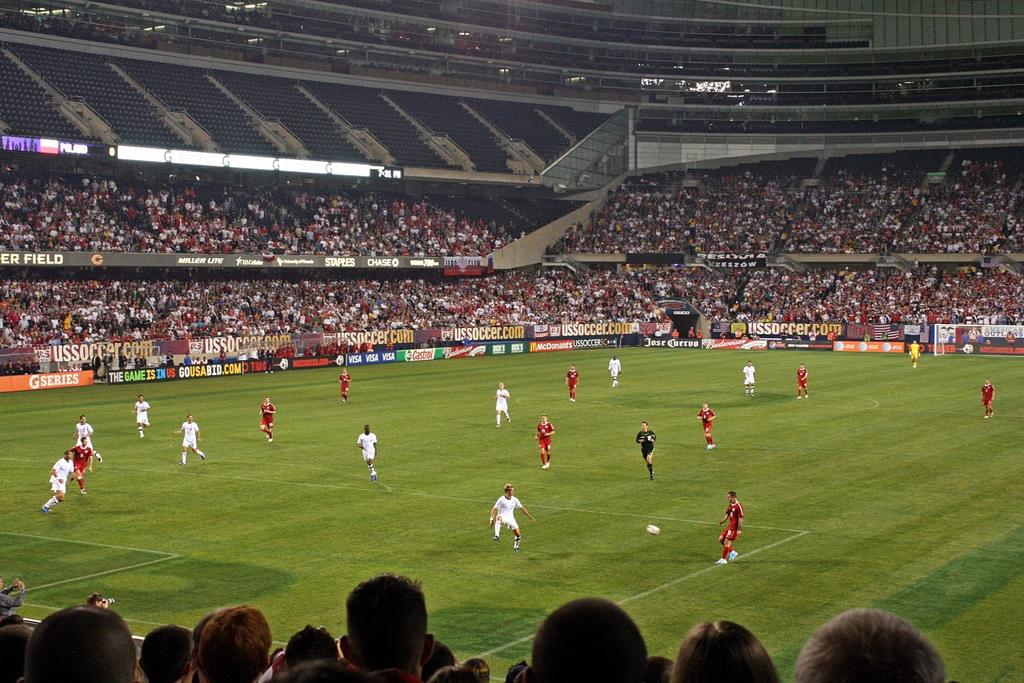What is us soccer's website?
Provide a succinct answer. Ussoccer.com. What is printed on the first banner?
Provide a short and direct response. G series. 